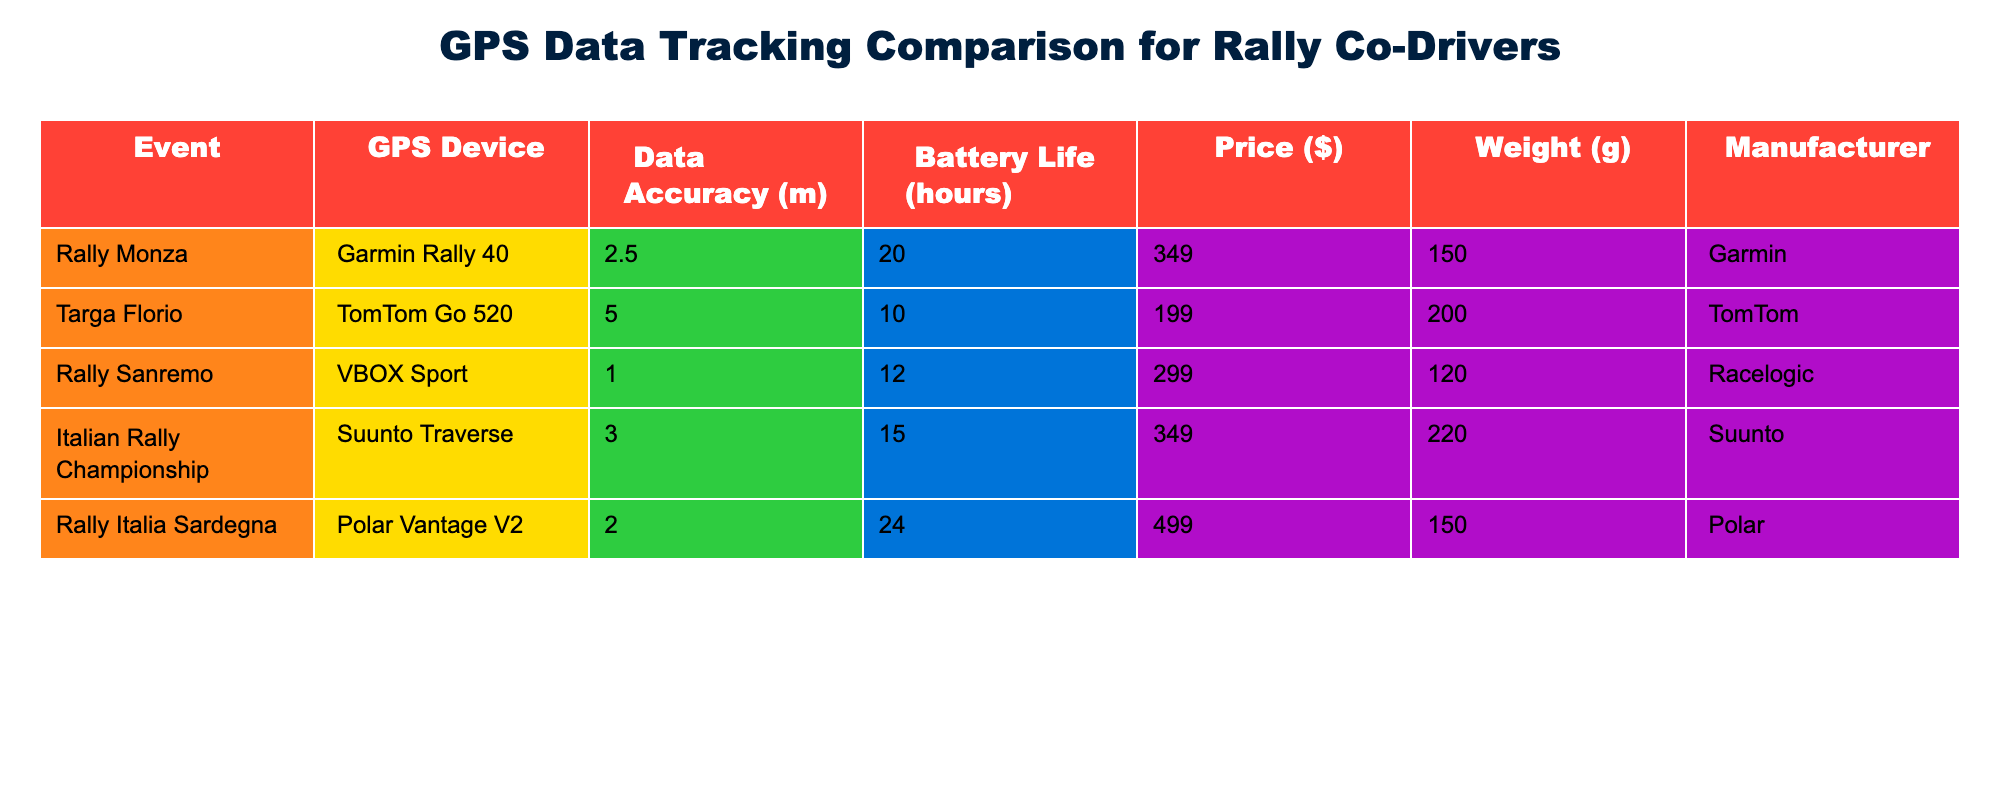What is the GPS device with the highest data accuracy? The GPS device with the highest data accuracy is VBOX Sport, which has a data accuracy of 1.0 meters. This can be found by looking at the Data Accuracy column and identifying the lowest value.
Answer: VBOX Sport Which GPS device has the longest battery life? The GPS device with the longest battery life is Polar Vantage V2, with a battery life of 24 hours, as seen in the Battery Life column among all entries.
Answer: Polar Vantage V2 How much does the Garmin Rally 40 cost? The cost of the Garmin Rally 40 is listed as 349 dollars in the Price column.
Answer: 349 Is there a GPS device that weighs less than 150 grams? Yes, both the VBOX Sport and the Garmin Rally 40 weigh 120 grams, which is less than 150 grams, as checked against the Weight column.
Answer: Yes What is the average battery life of the GPS devices listed? To find the average battery life, sum the battery lives: 20 + 10 + 12 + 15 + 24 = 91, and divide by the number of devices (5), giving 91/5 = 18.2 hours.
Answer: 18.2 Which manufacturer offers the most expensive GPS device, and what is its price? The most expensive GPS device is Polar Vantage V2, priced at 499 dollars. This was determined by examining the Price column and identifying the highest value.
Answer: Polar, 499 How much lighter is the Suunto Traverse compared to the TomTom Go 520? The Suunto Traverse weighs 220 grams, while the TomTom Go 520 weighs 200 grams. To find the difference, subtract: 220 - 200 = 20 grams.
Answer: 20 grams Are all the devices made by different manufacturers? No, there are two Garmin devices in the list, meaning not all devices are from different manufacturers. This can be confirmed by looking for repeated entries in the Manufacturer column.
Answer: No What percentage of the devices have a data accuracy of 2.5 meters or better? There are a total of 5 devices. The ones with data accuracy of 2.5 meters or better are the VBOX Sport (1.0), Polar Vantage V2 (2.0), and Garmin Rally 40 (2.5), totaling 3 devices. Thus, (3/5) * 100 = 60%.
Answer: 60% 